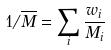<formula> <loc_0><loc_0><loc_500><loc_500>1 / \overline { M } = \sum _ { i } \frac { w _ { i } } { M _ { i } }</formula> 